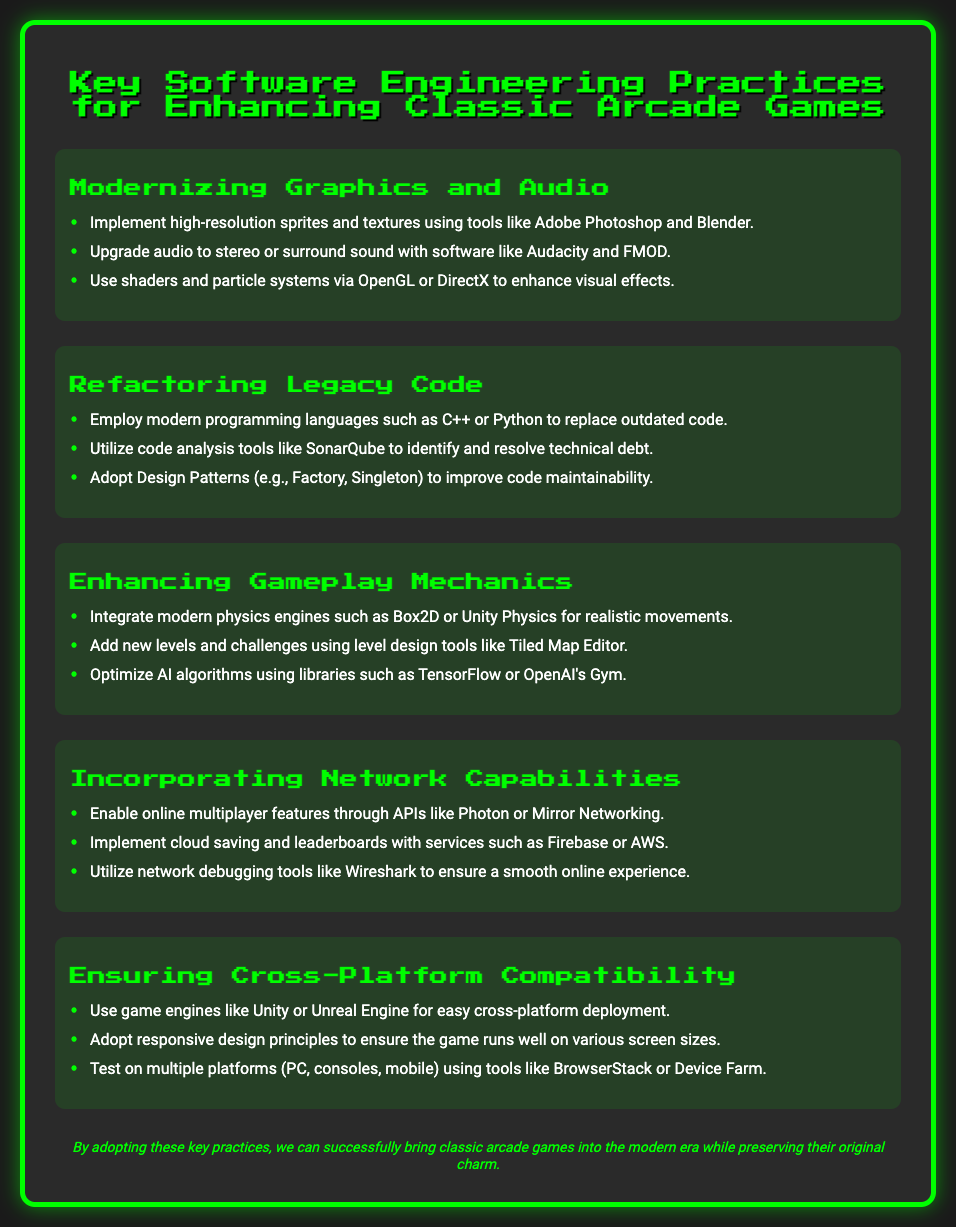What is the title of the poster? The title of the poster is presented at the top, introducing the main topic about enhancing classic arcade games.
Answer: Key Software Engineering Practices for Enhancing Classic Arcade Games How many sections are in the poster? The poster contains multiple sections, including the headings for each key practice.
Answer: Five What is one modern tool used for graphics? The document lists tools associated with modernizing graphics, specifically used for high-resolution sprites and textures.
Answer: Adobe Photoshop Which game engine is recommended for cross-platform deployment? The poster mentions specific game engines that allow for easy cross-platform deployment in one of its sections.
Answer: Unity What approach is suggested to identify technical debt? The document refers to using specific tools for analyzing code and identifying areas of technical improvement.
Answer: SonarQube What audio upgrade is mentioned? One of the recommended practices includes upgrading audio to enhance the gaming experience.
Answer: Stereo or surround sound Which library is recommended for optimizing AI algorithms? The document suggests specific libraries that can enhance how AI functions in the game development process.
Answer: TensorFlow What is the footer statement about? The footer summarizes the intent of adopting the practices discussed in the poster regarding classic arcade games.
Answer: Bringing classic arcade games into the modern era while preserving their original charm 